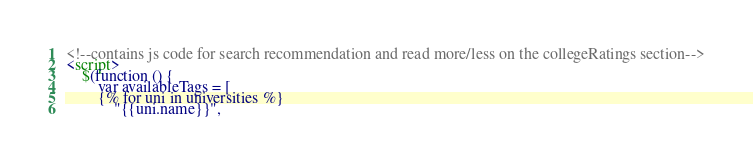<code> <loc_0><loc_0><loc_500><loc_500><_HTML_><!--contains js code for search recommendation and read more/less on the collegeRatings section-->
<script>
    $(function () {
        var availableTags = [
        {% for uni in universities %}
            "{{uni.name}}",</code> 